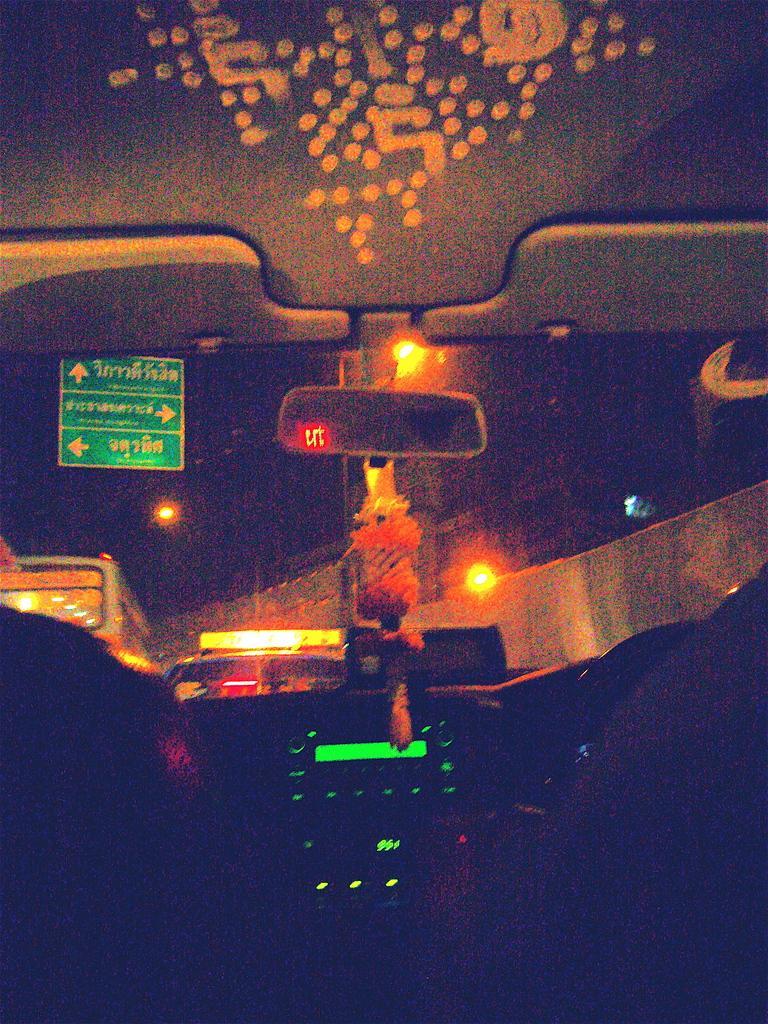Can you describe this image briefly? In this image I can see a inner part of the vehicle. I can see a mirror,green sign boards and lights. Background is dark. 